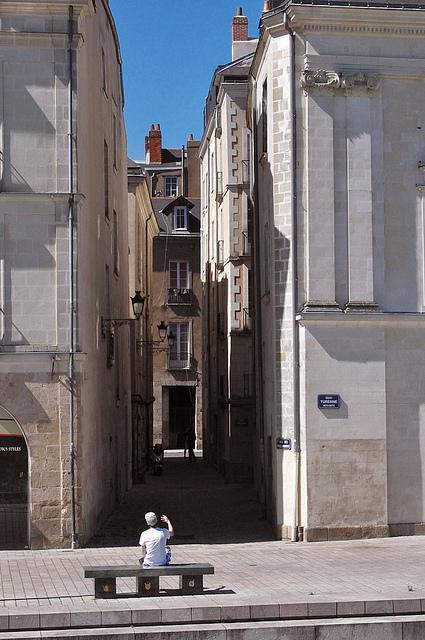Why does the man seated have his arm up?
Pick the right solution, then justify: 'Answer: answer
Rationale: rationale.'
Options: Measure, balance, gesture, break fall. Answer: gesture.
Rationale: The man is seated with his arm up to gesture at the alleyway. 